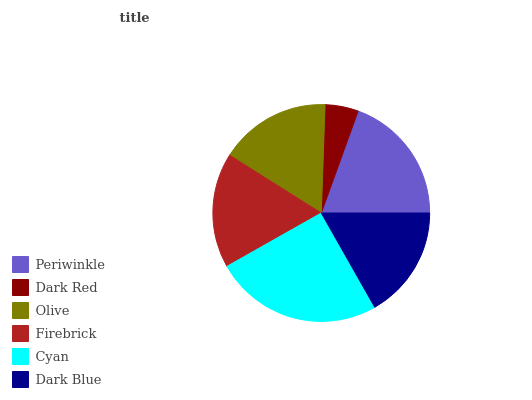Is Dark Red the minimum?
Answer yes or no. Yes. Is Cyan the maximum?
Answer yes or no. Yes. Is Olive the minimum?
Answer yes or no. No. Is Olive the maximum?
Answer yes or no. No. Is Olive greater than Dark Red?
Answer yes or no. Yes. Is Dark Red less than Olive?
Answer yes or no. Yes. Is Dark Red greater than Olive?
Answer yes or no. No. Is Olive less than Dark Red?
Answer yes or no. No. Is Firebrick the high median?
Answer yes or no. Yes. Is Dark Blue the low median?
Answer yes or no. Yes. Is Dark Red the high median?
Answer yes or no. No. Is Dark Red the low median?
Answer yes or no. No. 